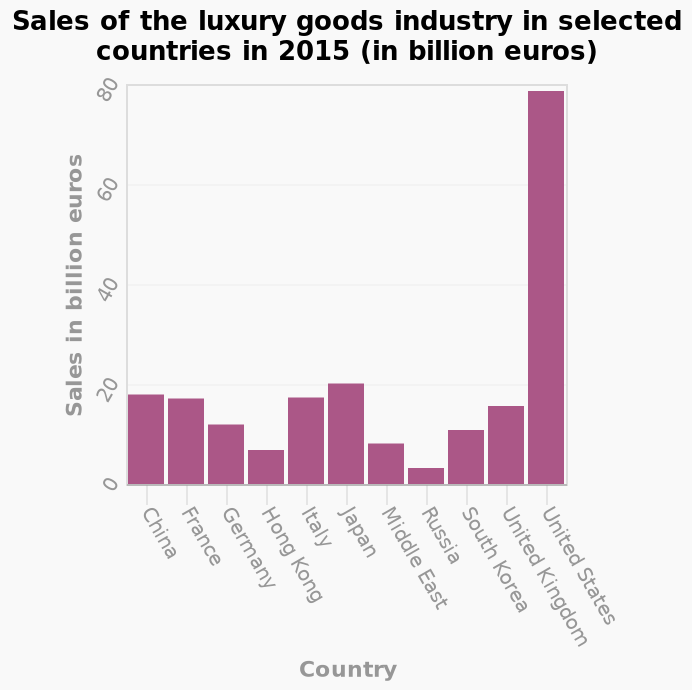<image>
What is the title of the bar plot?  The title of the bar plot is "Sales of the luxury goods industry in selected countries in 2015 (in billion euros)." Which country has the largest sales of luxury goods?  The USA has the largest sales of luxury goods. What is plotted on the x-axis of the bar plot?  On the x-axis, Country is plotted. 